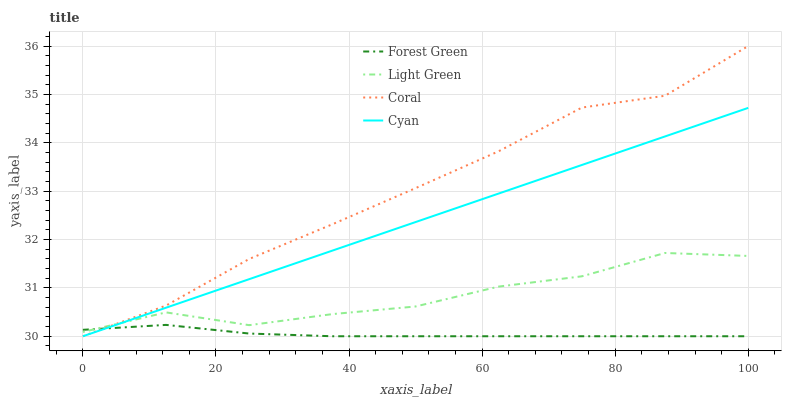Does Forest Green have the minimum area under the curve?
Answer yes or no. Yes. Does Coral have the maximum area under the curve?
Answer yes or no. Yes. Does Coral have the minimum area under the curve?
Answer yes or no. No. Does Forest Green have the maximum area under the curve?
Answer yes or no. No. Is Cyan the smoothest?
Answer yes or no. Yes. Is Light Green the roughest?
Answer yes or no. Yes. Is Forest Green the smoothest?
Answer yes or no. No. Is Forest Green the roughest?
Answer yes or no. No. Does Light Green have the lowest value?
Answer yes or no. No. Does Coral have the highest value?
Answer yes or no. Yes. Does Forest Green have the highest value?
Answer yes or no. No. Does Light Green intersect Cyan?
Answer yes or no. Yes. Is Light Green less than Cyan?
Answer yes or no. No. Is Light Green greater than Cyan?
Answer yes or no. No. 